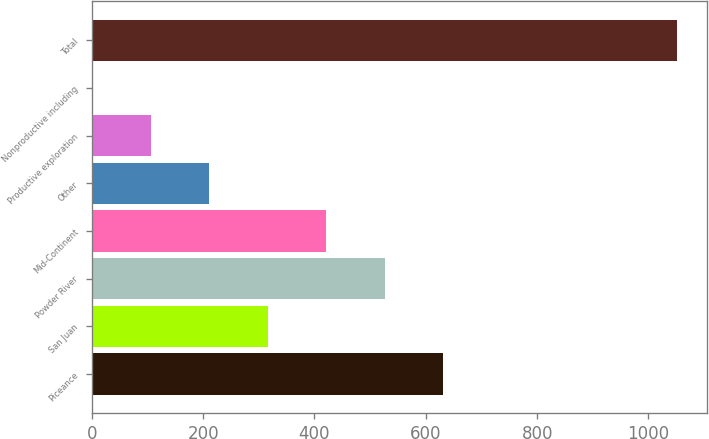<chart> <loc_0><loc_0><loc_500><loc_500><bar_chart><fcel>Piceance<fcel>San Juan<fcel>Powder River<fcel>Mid-Continent<fcel>Other<fcel>Productive exploration<fcel>Nonproductive including<fcel>Total<nl><fcel>631.4<fcel>315.98<fcel>526.26<fcel>421.12<fcel>210.84<fcel>105.7<fcel>0.56<fcel>1052<nl></chart> 